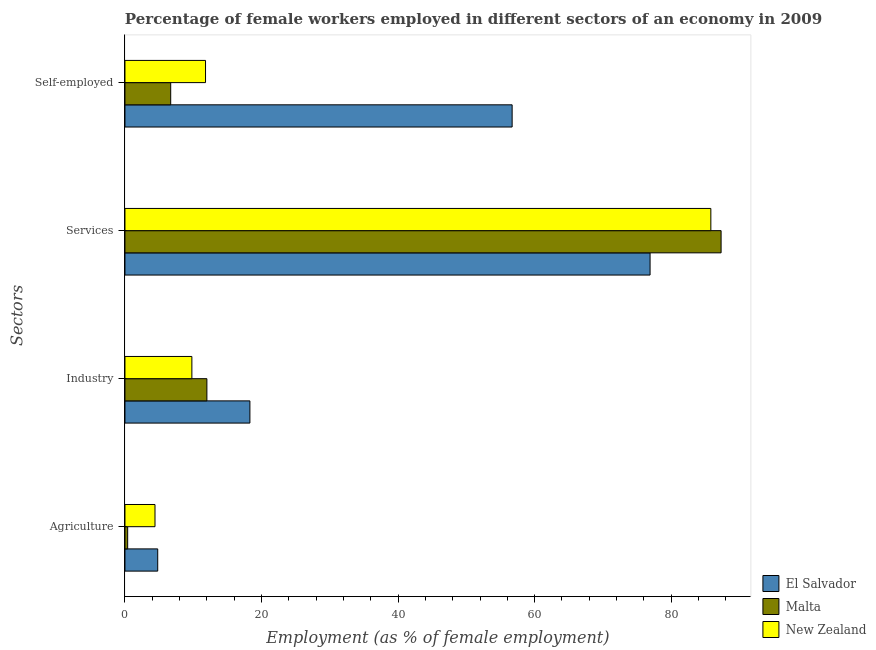How many groups of bars are there?
Your answer should be compact. 4. How many bars are there on the 4th tick from the bottom?
Ensure brevity in your answer.  3. What is the label of the 1st group of bars from the top?
Your response must be concise. Self-employed. What is the percentage of female workers in agriculture in El Salvador?
Give a very brief answer. 4.8. Across all countries, what is the maximum percentage of female workers in agriculture?
Make the answer very short. 4.8. Across all countries, what is the minimum percentage of self employed female workers?
Provide a short and direct response. 6.7. In which country was the percentage of self employed female workers maximum?
Offer a terse response. El Salvador. In which country was the percentage of self employed female workers minimum?
Ensure brevity in your answer.  Malta. What is the total percentage of female workers in industry in the graph?
Offer a terse response. 40.1. What is the difference between the percentage of female workers in agriculture in Malta and that in New Zealand?
Provide a succinct answer. -4. What is the difference between the percentage of self employed female workers in Malta and the percentage of female workers in agriculture in El Salvador?
Make the answer very short. 1.9. What is the average percentage of female workers in agriculture per country?
Give a very brief answer. 3.2. What is the difference between the percentage of self employed female workers and percentage of female workers in services in Malta?
Keep it short and to the point. -80.6. What is the ratio of the percentage of self employed female workers in Malta to that in New Zealand?
Provide a short and direct response. 0.57. What is the difference between the highest and the second highest percentage of self employed female workers?
Offer a very short reply. 44.9. What is the difference between the highest and the lowest percentage of self employed female workers?
Ensure brevity in your answer.  50. Is it the case that in every country, the sum of the percentage of female workers in agriculture and percentage of female workers in industry is greater than the sum of percentage of female workers in services and percentage of self employed female workers?
Offer a terse response. Yes. What does the 1st bar from the top in Agriculture represents?
Offer a terse response. New Zealand. What does the 1st bar from the bottom in Industry represents?
Ensure brevity in your answer.  El Salvador. Is it the case that in every country, the sum of the percentage of female workers in agriculture and percentage of female workers in industry is greater than the percentage of female workers in services?
Make the answer very short. No. How many bars are there?
Provide a succinct answer. 12. What is the difference between two consecutive major ticks on the X-axis?
Your answer should be very brief. 20. Are the values on the major ticks of X-axis written in scientific E-notation?
Give a very brief answer. No. Does the graph contain grids?
Your answer should be compact. No. Where does the legend appear in the graph?
Make the answer very short. Bottom right. How many legend labels are there?
Offer a very short reply. 3. How are the legend labels stacked?
Your answer should be compact. Vertical. What is the title of the graph?
Offer a very short reply. Percentage of female workers employed in different sectors of an economy in 2009. What is the label or title of the X-axis?
Offer a terse response. Employment (as % of female employment). What is the label or title of the Y-axis?
Give a very brief answer. Sectors. What is the Employment (as % of female employment) of El Salvador in Agriculture?
Provide a succinct answer. 4.8. What is the Employment (as % of female employment) of Malta in Agriculture?
Your answer should be very brief. 0.4. What is the Employment (as % of female employment) in New Zealand in Agriculture?
Offer a terse response. 4.4. What is the Employment (as % of female employment) in El Salvador in Industry?
Provide a short and direct response. 18.3. What is the Employment (as % of female employment) in Malta in Industry?
Your answer should be very brief. 12. What is the Employment (as % of female employment) in New Zealand in Industry?
Give a very brief answer. 9.8. What is the Employment (as % of female employment) of El Salvador in Services?
Keep it short and to the point. 76.9. What is the Employment (as % of female employment) in Malta in Services?
Your response must be concise. 87.3. What is the Employment (as % of female employment) of New Zealand in Services?
Your answer should be very brief. 85.8. What is the Employment (as % of female employment) of El Salvador in Self-employed?
Provide a succinct answer. 56.7. What is the Employment (as % of female employment) of Malta in Self-employed?
Your answer should be very brief. 6.7. What is the Employment (as % of female employment) of New Zealand in Self-employed?
Offer a terse response. 11.8. Across all Sectors, what is the maximum Employment (as % of female employment) of El Salvador?
Your response must be concise. 76.9. Across all Sectors, what is the maximum Employment (as % of female employment) of Malta?
Keep it short and to the point. 87.3. Across all Sectors, what is the maximum Employment (as % of female employment) in New Zealand?
Your response must be concise. 85.8. Across all Sectors, what is the minimum Employment (as % of female employment) of El Salvador?
Your answer should be compact. 4.8. Across all Sectors, what is the minimum Employment (as % of female employment) of Malta?
Provide a succinct answer. 0.4. Across all Sectors, what is the minimum Employment (as % of female employment) of New Zealand?
Ensure brevity in your answer.  4.4. What is the total Employment (as % of female employment) in El Salvador in the graph?
Provide a short and direct response. 156.7. What is the total Employment (as % of female employment) of Malta in the graph?
Make the answer very short. 106.4. What is the total Employment (as % of female employment) in New Zealand in the graph?
Provide a succinct answer. 111.8. What is the difference between the Employment (as % of female employment) in El Salvador in Agriculture and that in Industry?
Provide a succinct answer. -13.5. What is the difference between the Employment (as % of female employment) in Malta in Agriculture and that in Industry?
Offer a very short reply. -11.6. What is the difference between the Employment (as % of female employment) in El Salvador in Agriculture and that in Services?
Ensure brevity in your answer.  -72.1. What is the difference between the Employment (as % of female employment) of Malta in Agriculture and that in Services?
Give a very brief answer. -86.9. What is the difference between the Employment (as % of female employment) of New Zealand in Agriculture and that in Services?
Provide a short and direct response. -81.4. What is the difference between the Employment (as % of female employment) in El Salvador in Agriculture and that in Self-employed?
Make the answer very short. -51.9. What is the difference between the Employment (as % of female employment) of New Zealand in Agriculture and that in Self-employed?
Offer a very short reply. -7.4. What is the difference between the Employment (as % of female employment) in El Salvador in Industry and that in Services?
Keep it short and to the point. -58.6. What is the difference between the Employment (as % of female employment) of Malta in Industry and that in Services?
Provide a succinct answer. -75.3. What is the difference between the Employment (as % of female employment) of New Zealand in Industry and that in Services?
Give a very brief answer. -76. What is the difference between the Employment (as % of female employment) of El Salvador in Industry and that in Self-employed?
Your answer should be compact. -38.4. What is the difference between the Employment (as % of female employment) of New Zealand in Industry and that in Self-employed?
Give a very brief answer. -2. What is the difference between the Employment (as % of female employment) of El Salvador in Services and that in Self-employed?
Provide a succinct answer. 20.2. What is the difference between the Employment (as % of female employment) in Malta in Services and that in Self-employed?
Your answer should be very brief. 80.6. What is the difference between the Employment (as % of female employment) in El Salvador in Agriculture and the Employment (as % of female employment) in New Zealand in Industry?
Provide a succinct answer. -5. What is the difference between the Employment (as % of female employment) in El Salvador in Agriculture and the Employment (as % of female employment) in Malta in Services?
Offer a terse response. -82.5. What is the difference between the Employment (as % of female employment) in El Salvador in Agriculture and the Employment (as % of female employment) in New Zealand in Services?
Offer a very short reply. -81. What is the difference between the Employment (as % of female employment) in Malta in Agriculture and the Employment (as % of female employment) in New Zealand in Services?
Keep it short and to the point. -85.4. What is the difference between the Employment (as % of female employment) of El Salvador in Agriculture and the Employment (as % of female employment) of Malta in Self-employed?
Give a very brief answer. -1.9. What is the difference between the Employment (as % of female employment) of El Salvador in Industry and the Employment (as % of female employment) of Malta in Services?
Offer a very short reply. -69. What is the difference between the Employment (as % of female employment) of El Salvador in Industry and the Employment (as % of female employment) of New Zealand in Services?
Your answer should be very brief. -67.5. What is the difference between the Employment (as % of female employment) in Malta in Industry and the Employment (as % of female employment) in New Zealand in Services?
Your answer should be very brief. -73.8. What is the difference between the Employment (as % of female employment) in El Salvador in Services and the Employment (as % of female employment) in Malta in Self-employed?
Provide a short and direct response. 70.2. What is the difference between the Employment (as % of female employment) in El Salvador in Services and the Employment (as % of female employment) in New Zealand in Self-employed?
Your answer should be compact. 65.1. What is the difference between the Employment (as % of female employment) of Malta in Services and the Employment (as % of female employment) of New Zealand in Self-employed?
Keep it short and to the point. 75.5. What is the average Employment (as % of female employment) in El Salvador per Sectors?
Give a very brief answer. 39.17. What is the average Employment (as % of female employment) in Malta per Sectors?
Offer a very short reply. 26.6. What is the average Employment (as % of female employment) of New Zealand per Sectors?
Provide a short and direct response. 27.95. What is the difference between the Employment (as % of female employment) of El Salvador and Employment (as % of female employment) of Malta in Agriculture?
Offer a very short reply. 4.4. What is the difference between the Employment (as % of female employment) in El Salvador and Employment (as % of female employment) in New Zealand in Agriculture?
Provide a succinct answer. 0.4. What is the difference between the Employment (as % of female employment) in El Salvador and Employment (as % of female employment) in Malta in Industry?
Ensure brevity in your answer.  6.3. What is the difference between the Employment (as % of female employment) of El Salvador and Employment (as % of female employment) of New Zealand in Industry?
Your answer should be very brief. 8.5. What is the difference between the Employment (as % of female employment) in Malta and Employment (as % of female employment) in New Zealand in Industry?
Your answer should be very brief. 2.2. What is the difference between the Employment (as % of female employment) in Malta and Employment (as % of female employment) in New Zealand in Services?
Your answer should be very brief. 1.5. What is the difference between the Employment (as % of female employment) of El Salvador and Employment (as % of female employment) of Malta in Self-employed?
Provide a succinct answer. 50. What is the difference between the Employment (as % of female employment) of El Salvador and Employment (as % of female employment) of New Zealand in Self-employed?
Offer a terse response. 44.9. What is the difference between the Employment (as % of female employment) in Malta and Employment (as % of female employment) in New Zealand in Self-employed?
Your answer should be compact. -5.1. What is the ratio of the Employment (as % of female employment) of El Salvador in Agriculture to that in Industry?
Provide a short and direct response. 0.26. What is the ratio of the Employment (as % of female employment) of Malta in Agriculture to that in Industry?
Offer a very short reply. 0.03. What is the ratio of the Employment (as % of female employment) of New Zealand in Agriculture to that in Industry?
Offer a very short reply. 0.45. What is the ratio of the Employment (as % of female employment) in El Salvador in Agriculture to that in Services?
Your answer should be very brief. 0.06. What is the ratio of the Employment (as % of female employment) of Malta in Agriculture to that in Services?
Keep it short and to the point. 0. What is the ratio of the Employment (as % of female employment) of New Zealand in Agriculture to that in Services?
Offer a terse response. 0.05. What is the ratio of the Employment (as % of female employment) of El Salvador in Agriculture to that in Self-employed?
Provide a succinct answer. 0.08. What is the ratio of the Employment (as % of female employment) of Malta in Agriculture to that in Self-employed?
Keep it short and to the point. 0.06. What is the ratio of the Employment (as % of female employment) of New Zealand in Agriculture to that in Self-employed?
Offer a very short reply. 0.37. What is the ratio of the Employment (as % of female employment) of El Salvador in Industry to that in Services?
Make the answer very short. 0.24. What is the ratio of the Employment (as % of female employment) of Malta in Industry to that in Services?
Your answer should be compact. 0.14. What is the ratio of the Employment (as % of female employment) in New Zealand in Industry to that in Services?
Provide a succinct answer. 0.11. What is the ratio of the Employment (as % of female employment) in El Salvador in Industry to that in Self-employed?
Keep it short and to the point. 0.32. What is the ratio of the Employment (as % of female employment) in Malta in Industry to that in Self-employed?
Give a very brief answer. 1.79. What is the ratio of the Employment (as % of female employment) in New Zealand in Industry to that in Self-employed?
Make the answer very short. 0.83. What is the ratio of the Employment (as % of female employment) in El Salvador in Services to that in Self-employed?
Your answer should be very brief. 1.36. What is the ratio of the Employment (as % of female employment) of Malta in Services to that in Self-employed?
Offer a terse response. 13.03. What is the ratio of the Employment (as % of female employment) in New Zealand in Services to that in Self-employed?
Provide a short and direct response. 7.27. What is the difference between the highest and the second highest Employment (as % of female employment) of El Salvador?
Your answer should be very brief. 20.2. What is the difference between the highest and the second highest Employment (as % of female employment) of Malta?
Provide a succinct answer. 75.3. What is the difference between the highest and the lowest Employment (as % of female employment) in El Salvador?
Provide a succinct answer. 72.1. What is the difference between the highest and the lowest Employment (as % of female employment) of Malta?
Offer a terse response. 86.9. What is the difference between the highest and the lowest Employment (as % of female employment) in New Zealand?
Give a very brief answer. 81.4. 